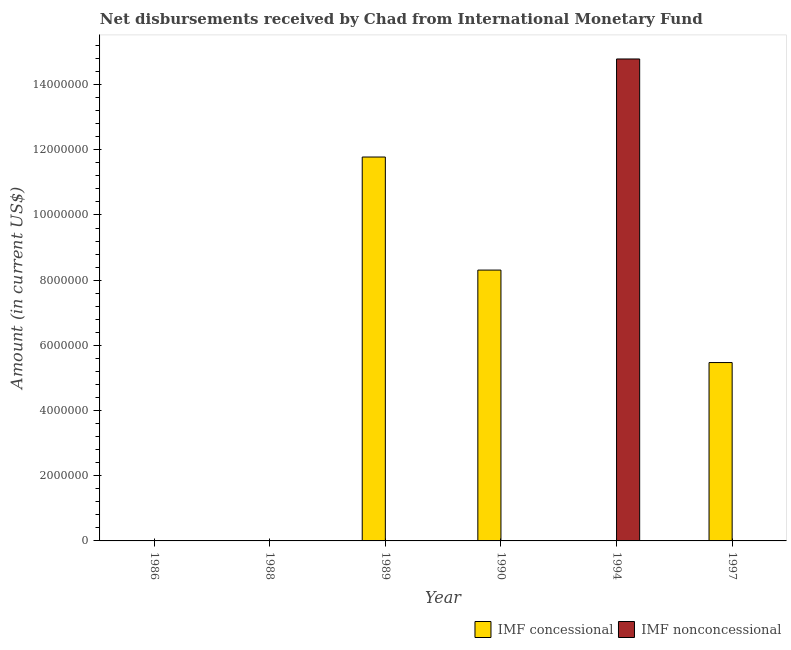What is the net concessional disbursements from imf in 1997?
Offer a very short reply. 5.47e+06. Across all years, what is the maximum net concessional disbursements from imf?
Provide a succinct answer. 1.18e+07. What is the total net concessional disbursements from imf in the graph?
Make the answer very short. 2.56e+07. What is the difference between the net non concessional disbursements from imf in 1997 and the net concessional disbursements from imf in 1990?
Your answer should be very brief. 0. What is the average net concessional disbursements from imf per year?
Offer a very short reply. 4.26e+06. In the year 1990, what is the difference between the net concessional disbursements from imf and net non concessional disbursements from imf?
Keep it short and to the point. 0. What is the difference between the highest and the second highest net concessional disbursements from imf?
Offer a very short reply. 3.47e+06. What is the difference between the highest and the lowest net concessional disbursements from imf?
Make the answer very short. 1.18e+07. How many years are there in the graph?
Keep it short and to the point. 6. How are the legend labels stacked?
Offer a very short reply. Horizontal. What is the title of the graph?
Offer a terse response. Net disbursements received by Chad from International Monetary Fund. What is the Amount (in current US$) in IMF concessional in 1986?
Your answer should be compact. 0. What is the Amount (in current US$) of IMF nonconcessional in 1986?
Your answer should be compact. 0. What is the Amount (in current US$) of IMF concessional in 1988?
Your answer should be very brief. 0. What is the Amount (in current US$) of IMF concessional in 1989?
Give a very brief answer. 1.18e+07. What is the Amount (in current US$) of IMF concessional in 1990?
Make the answer very short. 8.31e+06. What is the Amount (in current US$) of IMF nonconcessional in 1990?
Offer a very short reply. 0. What is the Amount (in current US$) in IMF concessional in 1994?
Give a very brief answer. 0. What is the Amount (in current US$) in IMF nonconcessional in 1994?
Give a very brief answer. 1.48e+07. What is the Amount (in current US$) in IMF concessional in 1997?
Your answer should be very brief. 5.47e+06. What is the Amount (in current US$) in IMF nonconcessional in 1997?
Keep it short and to the point. 0. Across all years, what is the maximum Amount (in current US$) in IMF concessional?
Offer a very short reply. 1.18e+07. Across all years, what is the maximum Amount (in current US$) of IMF nonconcessional?
Give a very brief answer. 1.48e+07. What is the total Amount (in current US$) of IMF concessional in the graph?
Give a very brief answer. 2.56e+07. What is the total Amount (in current US$) in IMF nonconcessional in the graph?
Keep it short and to the point. 1.48e+07. What is the difference between the Amount (in current US$) of IMF concessional in 1989 and that in 1990?
Provide a short and direct response. 3.47e+06. What is the difference between the Amount (in current US$) of IMF concessional in 1989 and that in 1997?
Your answer should be compact. 6.31e+06. What is the difference between the Amount (in current US$) in IMF concessional in 1990 and that in 1997?
Offer a very short reply. 2.84e+06. What is the difference between the Amount (in current US$) in IMF concessional in 1989 and the Amount (in current US$) in IMF nonconcessional in 1994?
Give a very brief answer. -3.01e+06. What is the difference between the Amount (in current US$) in IMF concessional in 1990 and the Amount (in current US$) in IMF nonconcessional in 1994?
Ensure brevity in your answer.  -6.48e+06. What is the average Amount (in current US$) of IMF concessional per year?
Provide a short and direct response. 4.26e+06. What is the average Amount (in current US$) of IMF nonconcessional per year?
Offer a very short reply. 2.46e+06. What is the ratio of the Amount (in current US$) in IMF concessional in 1989 to that in 1990?
Offer a terse response. 1.42. What is the ratio of the Amount (in current US$) in IMF concessional in 1989 to that in 1997?
Offer a very short reply. 2.15. What is the ratio of the Amount (in current US$) of IMF concessional in 1990 to that in 1997?
Ensure brevity in your answer.  1.52. What is the difference between the highest and the second highest Amount (in current US$) of IMF concessional?
Your answer should be very brief. 3.47e+06. What is the difference between the highest and the lowest Amount (in current US$) in IMF concessional?
Provide a short and direct response. 1.18e+07. What is the difference between the highest and the lowest Amount (in current US$) in IMF nonconcessional?
Your answer should be compact. 1.48e+07. 